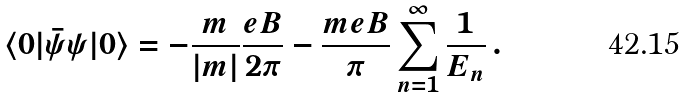<formula> <loc_0><loc_0><loc_500><loc_500>\langle 0 | { \bar { \psi } } \psi | 0 \rangle = - \frac { m } { | m | } \frac { e B } { 2 \pi } - \frac { m e B } { \pi } \sum _ { n = 1 } ^ { \infty } \frac { 1 } { E _ { n } } \, .</formula> 